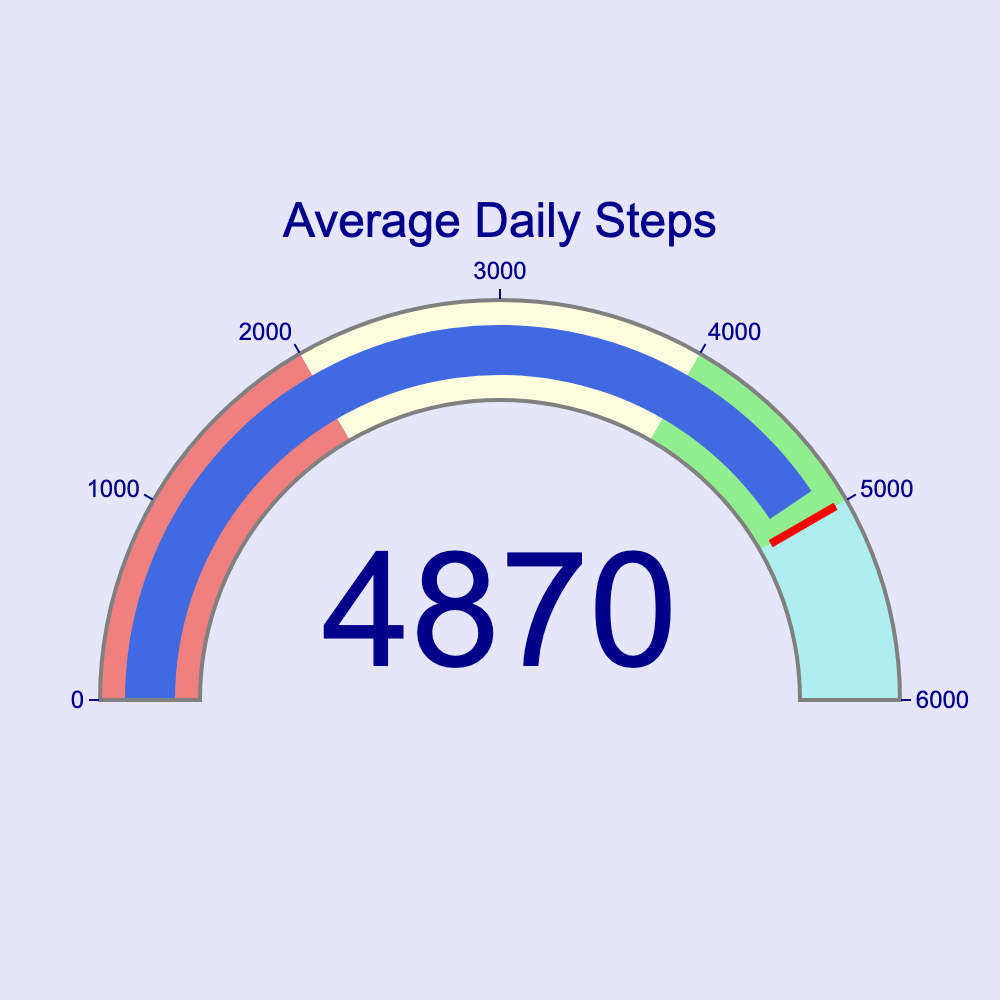What is the title of the gauge chart? The title of the gauge chart is displayed at the top and reads "Average Daily Steps."
Answer: Average Daily Steps What range does the gauge's axis cover? The gauge's axis range is indicated on the chart with tick marks from 0 to 6000.
Answer: 0 to 6000 What color is the bar indicator on the gauge chart? The bar indicator in the gauge chart is colored in royal blue.
Answer: Royal blue What is the threshold value set on the gauge chart? The threshold value is represented by a red line on the gauge chart and it is set at 5000 steps.
Answer: 5000 steps In which color zone does the average daily steps value lie? The average daily steps value falls in the light green zone on the chart, indicating it is between 4000 and 5000 steps.
Answer: Light green What is the average daily steps value displayed on the gauge chart? The value displayed in the center of the gauge chart is the average daily steps, which is approximately 4871 steps.
Answer: 4871 steps What is the goal daily step count for the rehabilitation? The goal daily step count is represented by the threshold line, which is set at 5000 steps.
Answer: 5000 steps What is the name of the color zone that ranges from 0 to 2000 steps? The color zone that ranges from 0 to 2000 steps is labeled with a light coral color.
Answer: Light coral How does the average daily step count compare to the goal? The average daily step count is slightly below the goal as 4871 steps is less than the threshold of 5000 steps.
Answer: Less than What do the different color zones on the gauge chart indicate? The different color zones represent various levels of daily steps: light coral (0-2000), light yellow (2000-4000), light green (4000-5000), and paleturquoise (5000-6000).
Answer: Levels of daily steps 